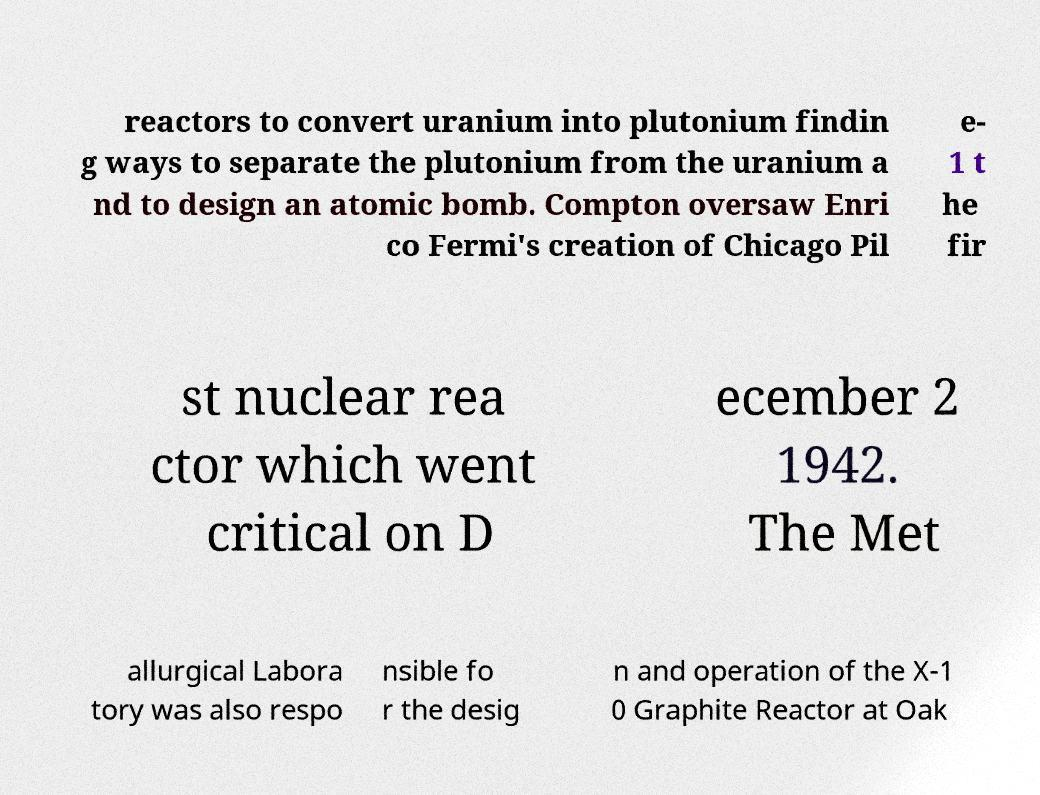Can you read and provide the text displayed in the image?This photo seems to have some interesting text. Can you extract and type it out for me? reactors to convert uranium into plutonium findin g ways to separate the plutonium from the uranium a nd to design an atomic bomb. Compton oversaw Enri co Fermi's creation of Chicago Pil e- 1 t he fir st nuclear rea ctor which went critical on D ecember 2 1942. The Met allurgical Labora tory was also respo nsible fo r the desig n and operation of the X-1 0 Graphite Reactor at Oak 